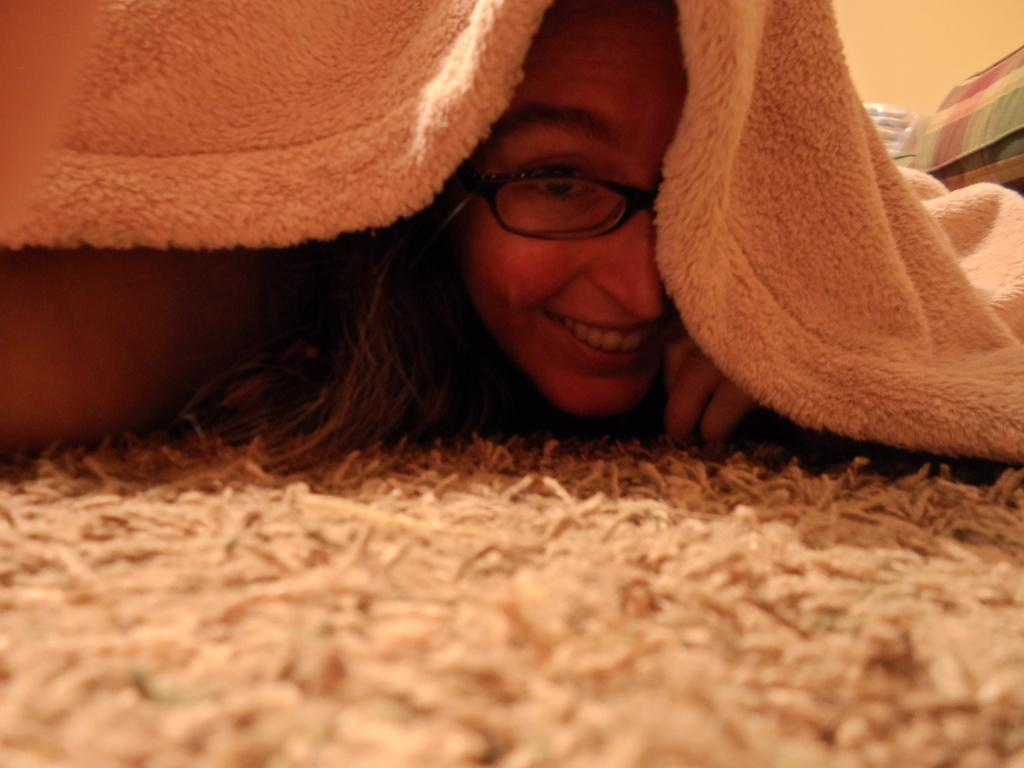Who is the main subject in the image? There is a woman in the image. What is the woman doing in the image? The woman is lying on a carpet. Is there anything covering the woman? Yes, there is a blanket on the woman. What can be seen on the right side of the image? There are objects on the right side of the image. What type of fruit is the woman holding in the image? There is no fruit present in the image; the woman is lying on a carpet with a blanket on her. 